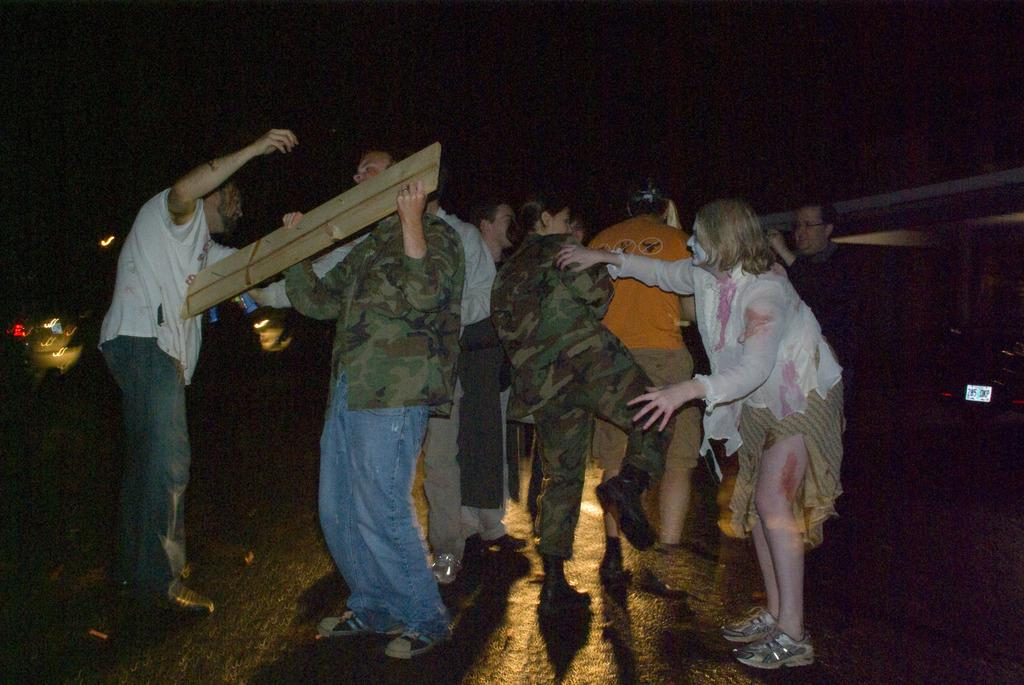What is happening on the road in the image? There is a group of people on the road in the image. What else can be seen on the road besides the people? Vehicles are present in the image. What can be seen in the background of the image? Buildings are present in the image. What is the time of day in the image? The image appears to be taken during the night. How does the overall appearance of the image reflect the time of day? The overall color scheme of the image is dark. What type of pencil is being used to draw on the potato in the image? There is no pencil or potato present in the image. What kind of error can be seen in the image? There is no error present in the image; it appears to be a clear and accurate representation of the scene. 